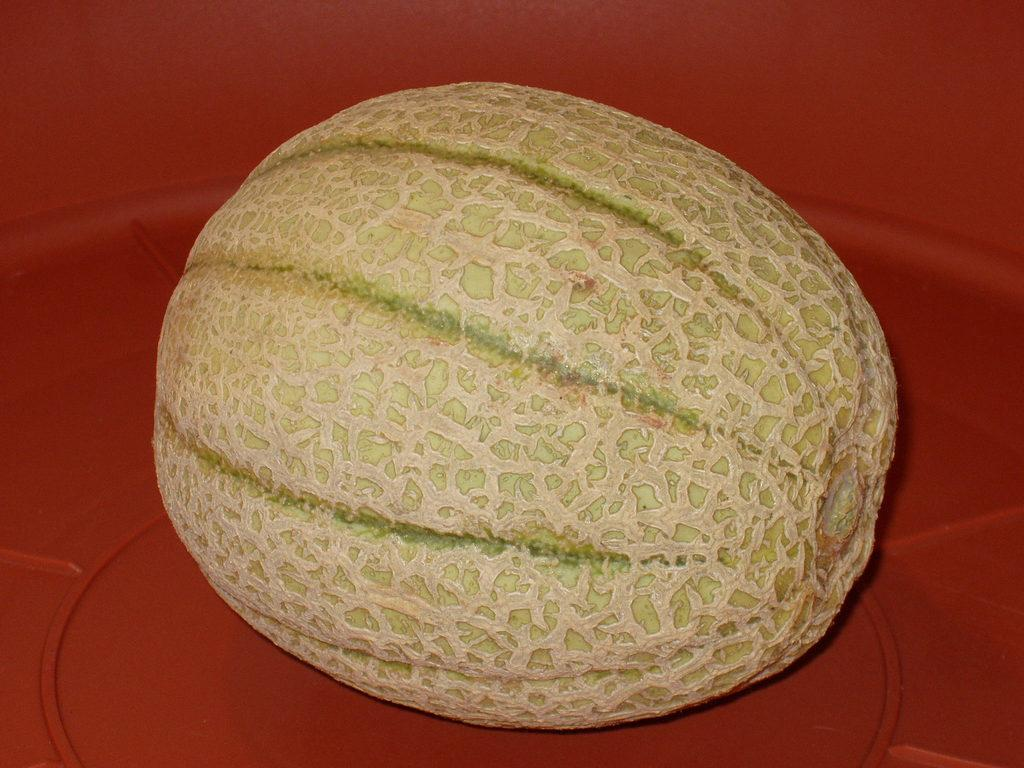What type of fruit is present in the image? There is a melon in the image. What color is the background of the image? The background of the image is red in color. How many passengers are riding the horse in the image? There is no horse or passengers present in the image; it features a melon with a red background. 